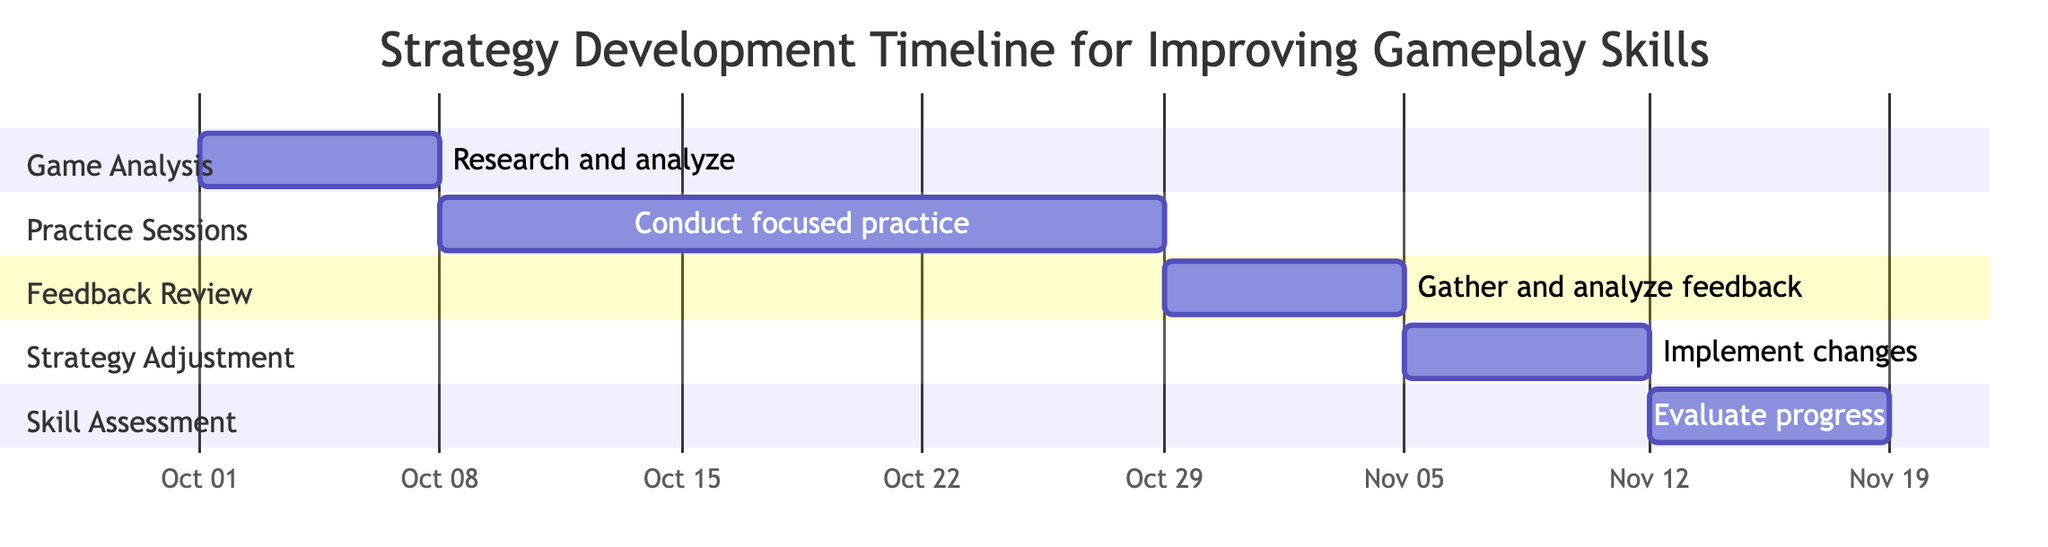What is the duration of the Game Analysis task? The duration of the Game Analysis task is specified directly in the diagram as "1 week."
Answer: 1 week When does the Practice Sessions task start? The start date of the Practice Sessions task is clearly marked in the diagram as "2023-10-08."
Answer: 2023-10-08 How many total tasks are represented in the diagram? By counting the sections on the Gantt chart (Game Analysis, Practice Sessions, Feedback Review, Strategy Adjustment, Skill Assessment), we see there are a total of five tasks.
Answer: 5 What is the end date of the Feedback Review task? The diagram indicates the end date of the Feedback Review task as "2023-11-04."
Answer: 2023-11-04 Which task follows the Strategy Adjustment task? If we look at the structure of the diagram, after the Strategy Adjustment task (ending on 2023-11-11), the next task is the Skill Assessment task (starting on 2023-11-12).
Answer: Skill Assessment What are the tasks with durations longer than one week? By reviewing the durations listed in the diagram, only the Practice Sessions task has a duration of "3 weeks" which is longer than one week.
Answer: Practice Sessions What is the time gap between the end of Practice Sessions and the start of Feedback Review? The Practice Sessions task ends on "2023-10-28," and the Feedback Review starts on "2023-10-29," so there is a gap of one day between them.
Answer: 1 day Which task has the shortest duration? The tasks with the shortest duration are Game Analysis, Feedback Review, Strategy Adjustment, and Skill Assessment, each having a duration of "1 week."
Answer: Game Analysis, Feedback Review, Strategy Adjustment, Skill Assessment What task occurs concurrently with the Feedback Review task? Analysis of the timeline shows that no tasks overlap with Feedback Review, as the preceding task (Practice Sessions) ends immediately before it starts, making them sequential instead of concurrent.
Answer: None 